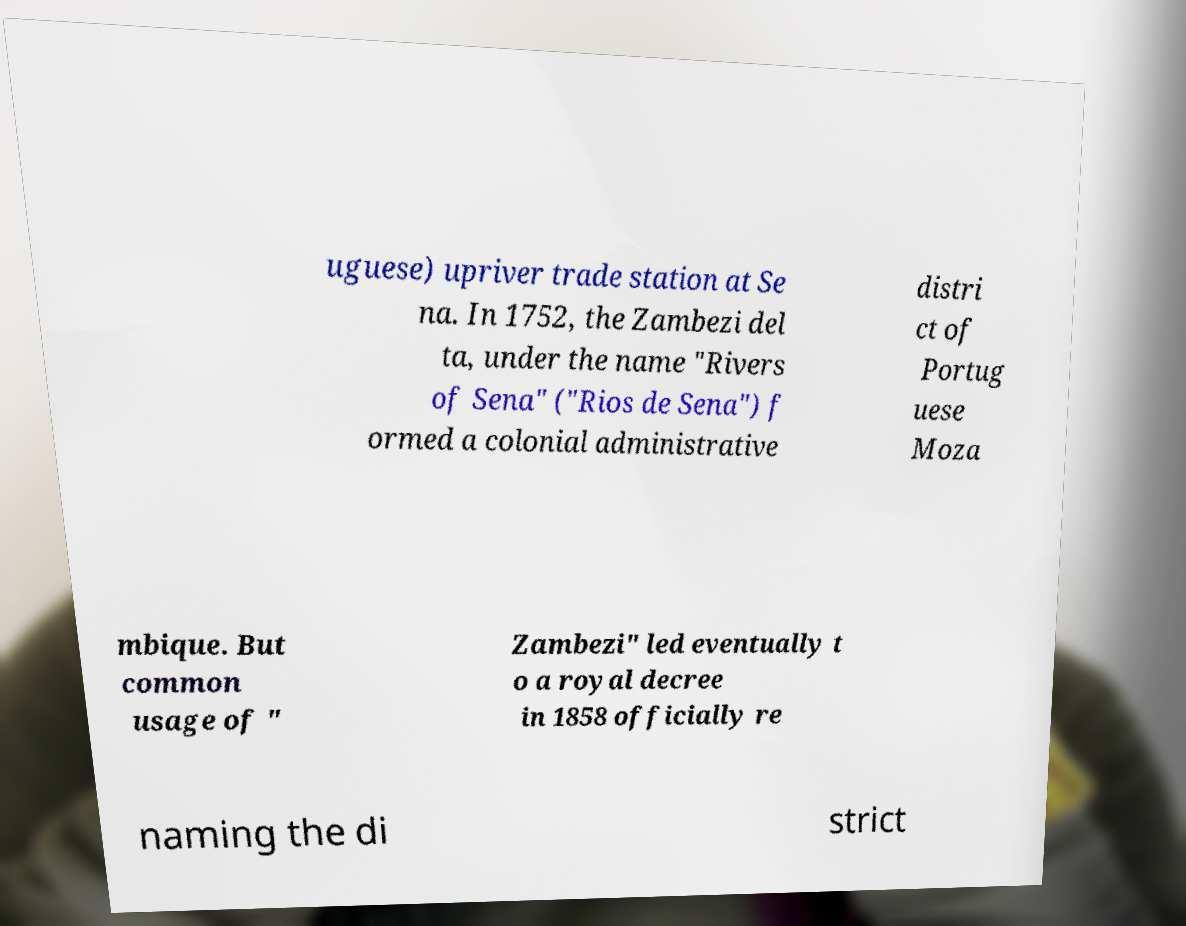Can you read and provide the text displayed in the image?This photo seems to have some interesting text. Can you extract and type it out for me? uguese) upriver trade station at Se na. In 1752, the Zambezi del ta, under the name "Rivers of Sena" ("Rios de Sena") f ormed a colonial administrative distri ct of Portug uese Moza mbique. But common usage of " Zambezi" led eventually t o a royal decree in 1858 officially re naming the di strict 